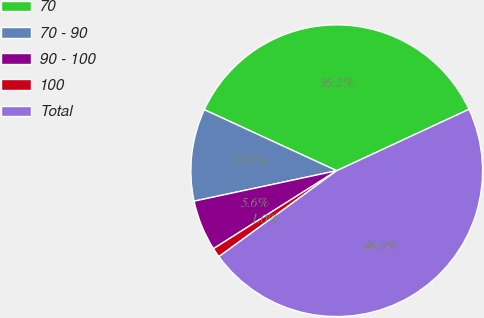<chart> <loc_0><loc_0><loc_500><loc_500><pie_chart><fcel>70<fcel>70 - 90<fcel>90 - 100<fcel>100<fcel>Total<nl><fcel>36.21%<fcel>10.22%<fcel>5.63%<fcel>1.05%<fcel>46.89%<nl></chart> 